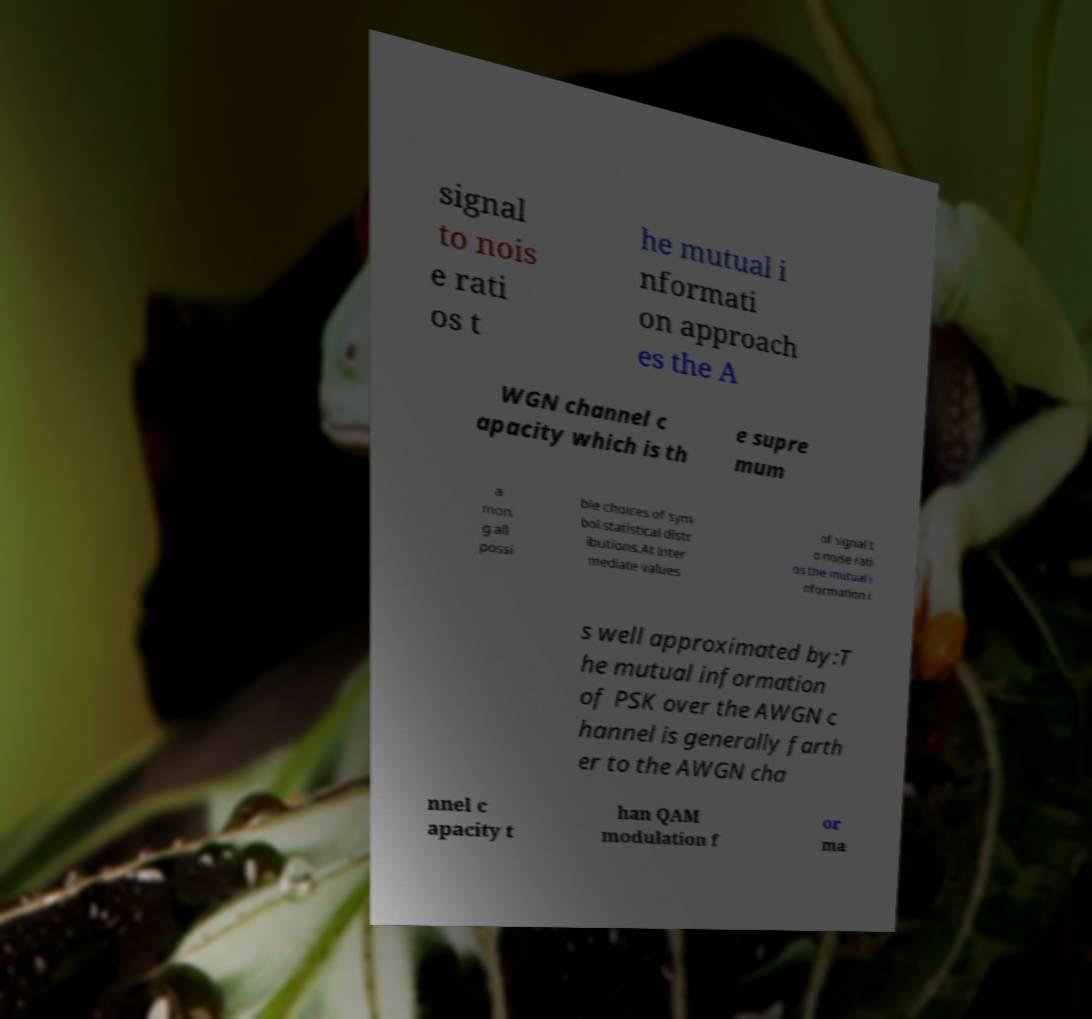Can you read and provide the text displayed in the image?This photo seems to have some interesting text. Can you extract and type it out for me? signal to nois e rati os t he mutual i nformati on approach es the A WGN channel c apacity which is th e supre mum a mon g all possi ble choices of sym bol statistical distr ibutions.At inter mediate values of signal t o noise rati os the mutual i nformation i s well approximated by:T he mutual information of PSK over the AWGN c hannel is generally farth er to the AWGN cha nnel c apacity t han QAM modulation f or ma 